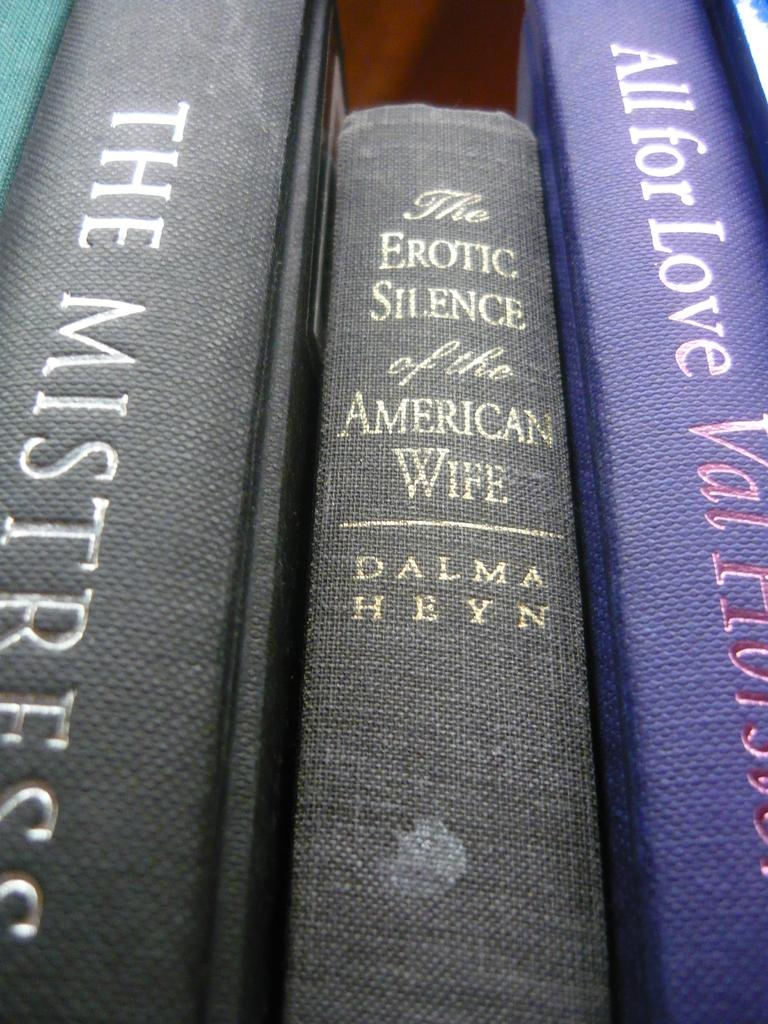<image>
Render a clear and concise summary of the photo. Hardcover books are on a bookshelf, one of the titles being "The Erotic Silence of the American Wife." 